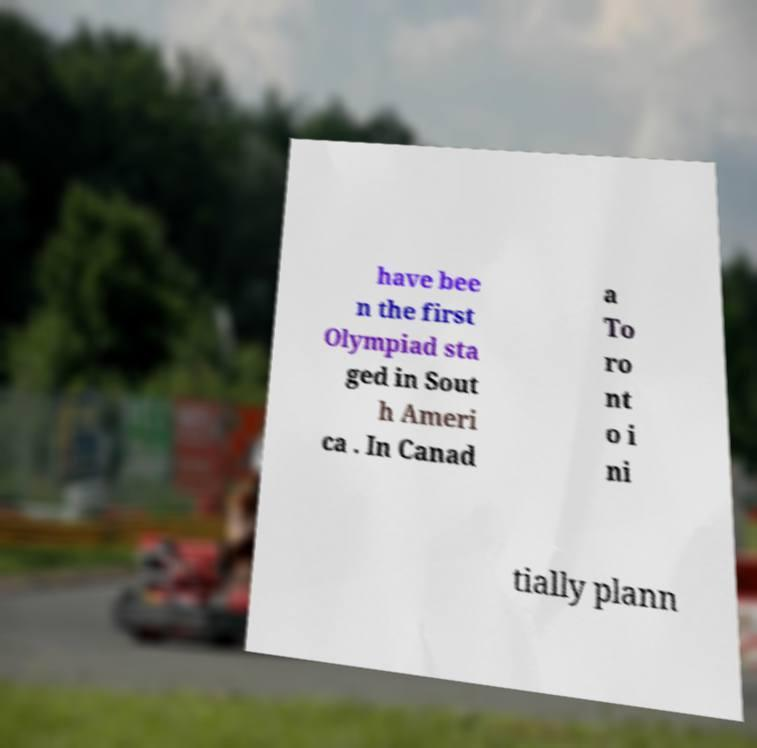Could you assist in decoding the text presented in this image and type it out clearly? have bee n the first Olympiad sta ged in Sout h Ameri ca . In Canad a To ro nt o i ni tially plann 